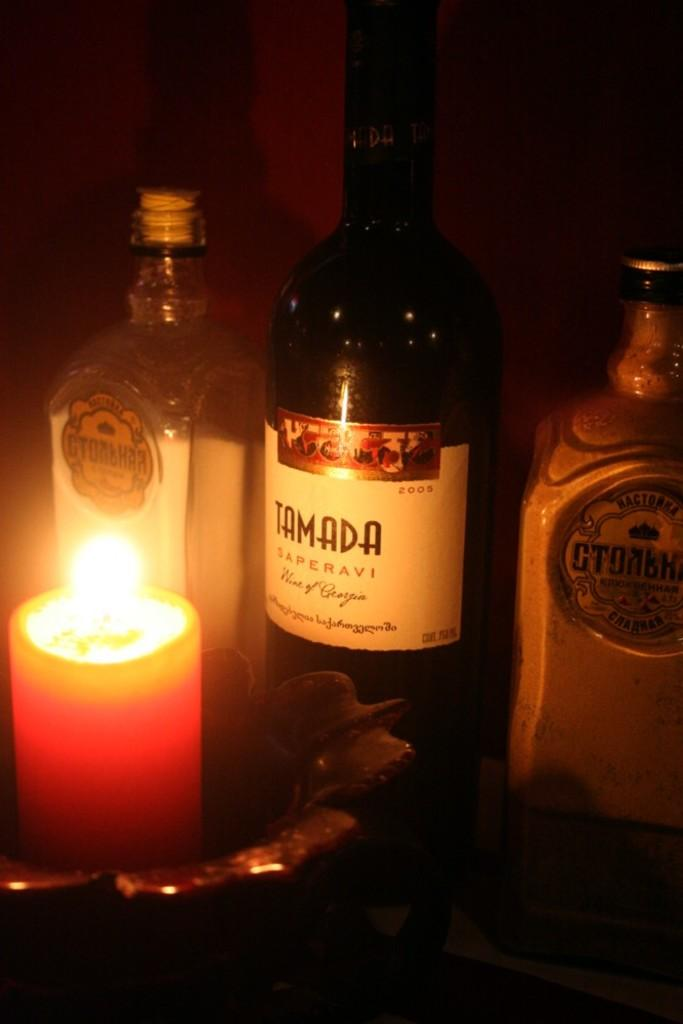How many candles are visible in the image? There are three candles in the image. Is there any other candle arrangement in the image? Yes, there is a candle placed in a bowl in front of the three candles. What type of fiction is being read by the candles in the image? There is no indication in the image that the candles are reading any fiction, as candles are inanimate objects and cannot read. 